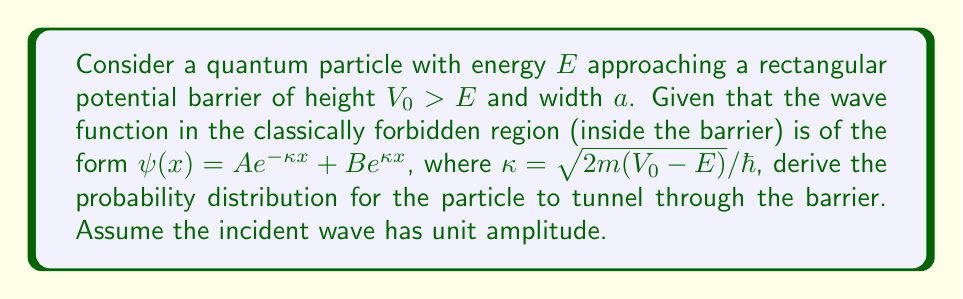Show me your answer to this math problem. 1) First, we need to set up the wave functions in all three regions:
   Region I (before barrier): $\psi_I(x) = e^{ikx} + Re^{-ikx}$
   Region II (inside barrier): $\psi_{II}(x) = Ae^{-\kappa x} + Be^{\kappa x}$
   Region III (after barrier): $\psi_{III}(x) = Te^{ikx}$

   Where $k = \sqrt{2mE}/\hbar$, $R$ is the reflection coefficient, and $T$ is the transmission coefficient.

2) Apply the boundary conditions at $x=0$ and $x=a$:
   $\psi_I(0) = \psi_{II}(0)$
   $\psi'_I(0) = \psi'_{II}(0)$
   $\psi_{II}(a) = \psi_{III}(a)$
   $\psi'_{II}(a) = \psi'_{III}(a)$

3) Solve the resulting system of equations. After some algebra, we get:
   $T = \frac{4ik\kappa e^{-ika}}{(k+i\kappa)^2e^{-\kappa a} - (k-i\kappa)^2e^{\kappa a}}$

4) The probability of tunneling is given by the transmission coefficient $|T|^2$:
   $$|T|^2 = \frac{1}{1 + \frac{(k^2+\kappa^2)^2}{4k^2\kappa^2}\sinh^2(\kappa a)}$$

5) This can be simplified using the approximation $\sinh^2(\kappa a) \approx \frac{1}{4}e^{2\kappa a}$ for large $\kappa a$:
   $$|T|^2 \approx 16\frac{E(V_0-E)}{V_0^2}e^{-2\kappa a}$$

6) The probability distribution is then:
   $$P(E) = 16\frac{E(V_0-E)}{V_0^2}\exp\left(-2a\sqrt{\frac{2m(V_0-E)}{\hbar^2}}\right)$$
Answer: $P(E) = 16\frac{E(V_0-E)}{V_0^2}\exp\left(-2a\sqrt{\frac{2m(V_0-E)}{\hbar^2}}\right)$ 